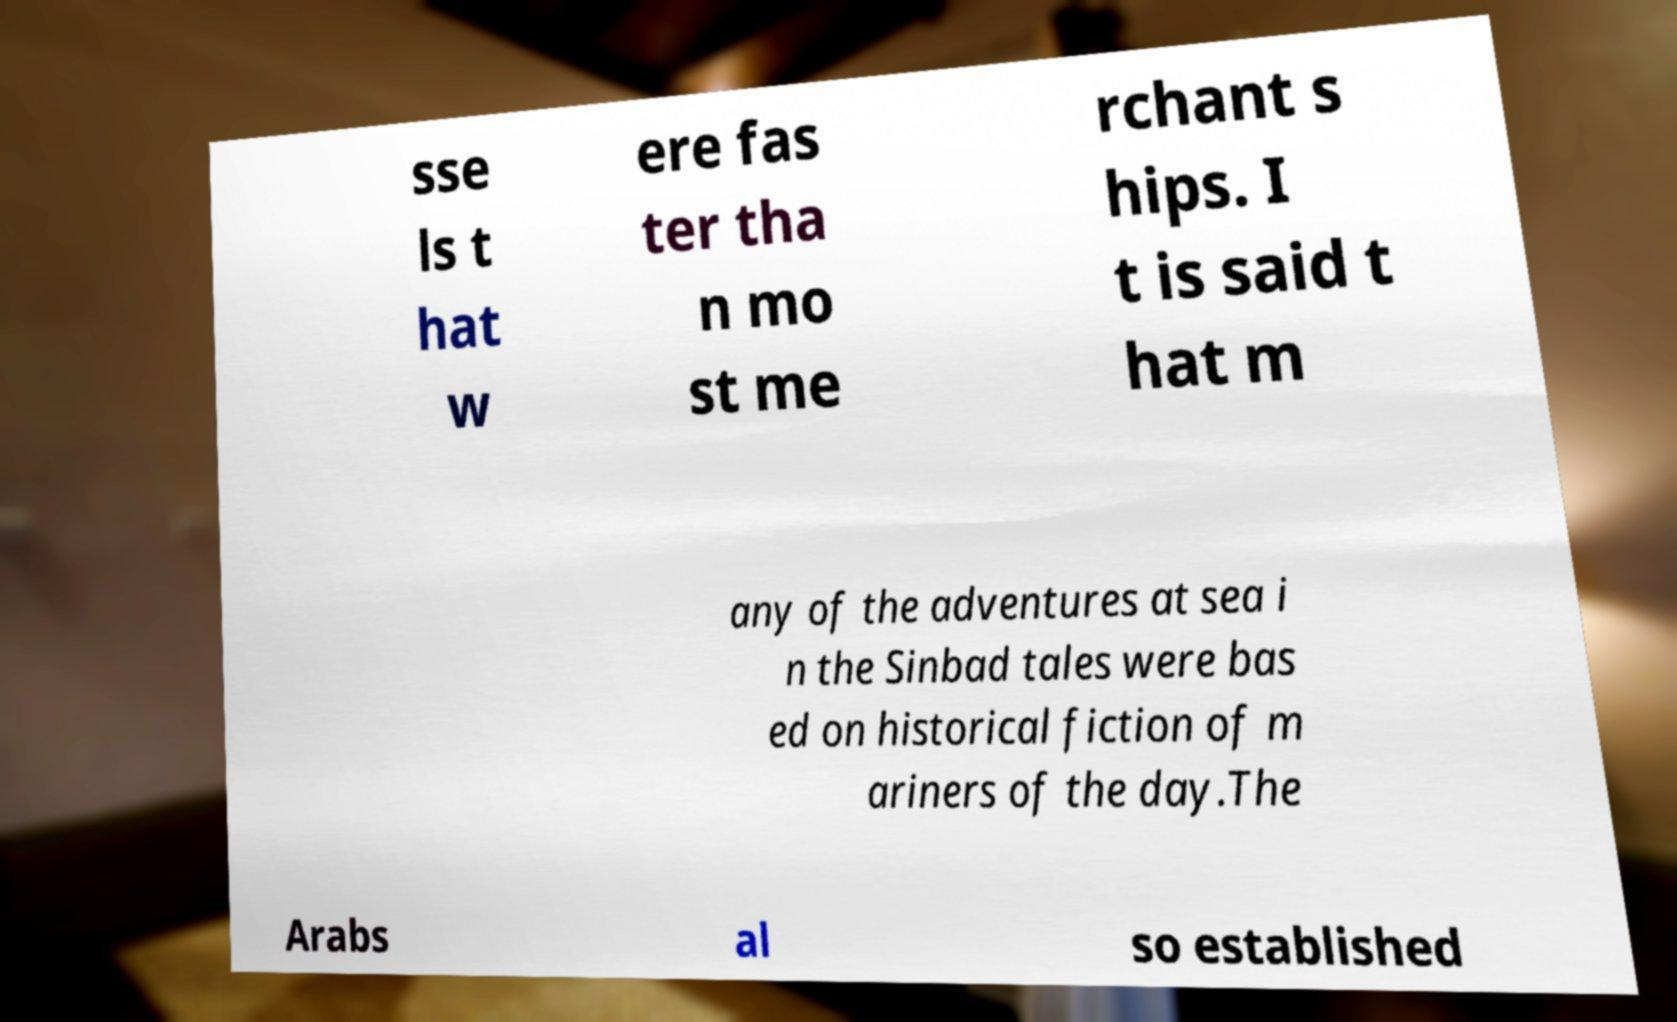Please identify and transcribe the text found in this image. sse ls t hat w ere fas ter tha n mo st me rchant s hips. I t is said t hat m any of the adventures at sea i n the Sinbad tales were bas ed on historical fiction of m ariners of the day.The Arabs al so established 